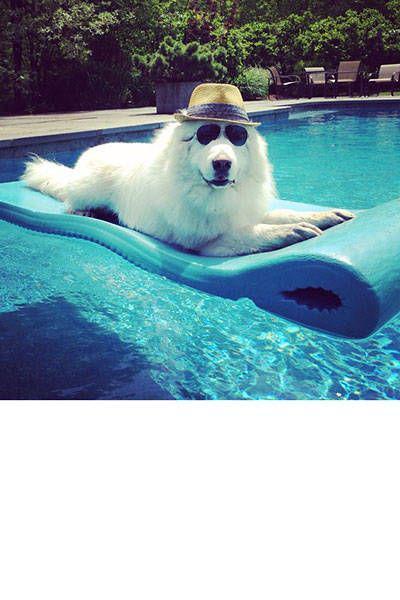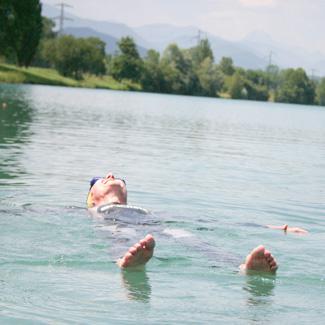The first image is the image on the left, the second image is the image on the right. Evaluate the accuracy of this statement regarding the images: "At least one image shows a dog actually swimming in a pool.". Is it true? Answer yes or no. No. The first image is the image on the left, the second image is the image on the right. Evaluate the accuracy of this statement regarding the images: "There is a person in the water in one of the images.". Is it true? Answer yes or no. Yes. 